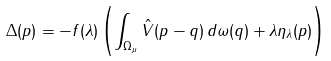<formula> <loc_0><loc_0><loc_500><loc_500>\Delta ( p ) = - f ( \lambda ) \left ( \int _ { \Omega _ { \mu } } \hat { V } ( p - q ) \, d \omega ( q ) + \lambda \eta _ { \lambda } ( p ) \right )</formula> 